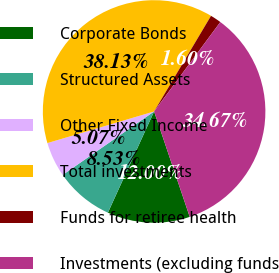Convert chart to OTSL. <chart><loc_0><loc_0><loc_500><loc_500><pie_chart><fcel>Corporate Bonds<fcel>Structured Assets<fcel>Other Fixed Income<fcel>Total investments<fcel>Funds for retiree health<fcel>Investments (excluding funds<nl><fcel>12.0%<fcel>8.53%<fcel>5.07%<fcel>38.13%<fcel>1.6%<fcel>34.67%<nl></chart> 